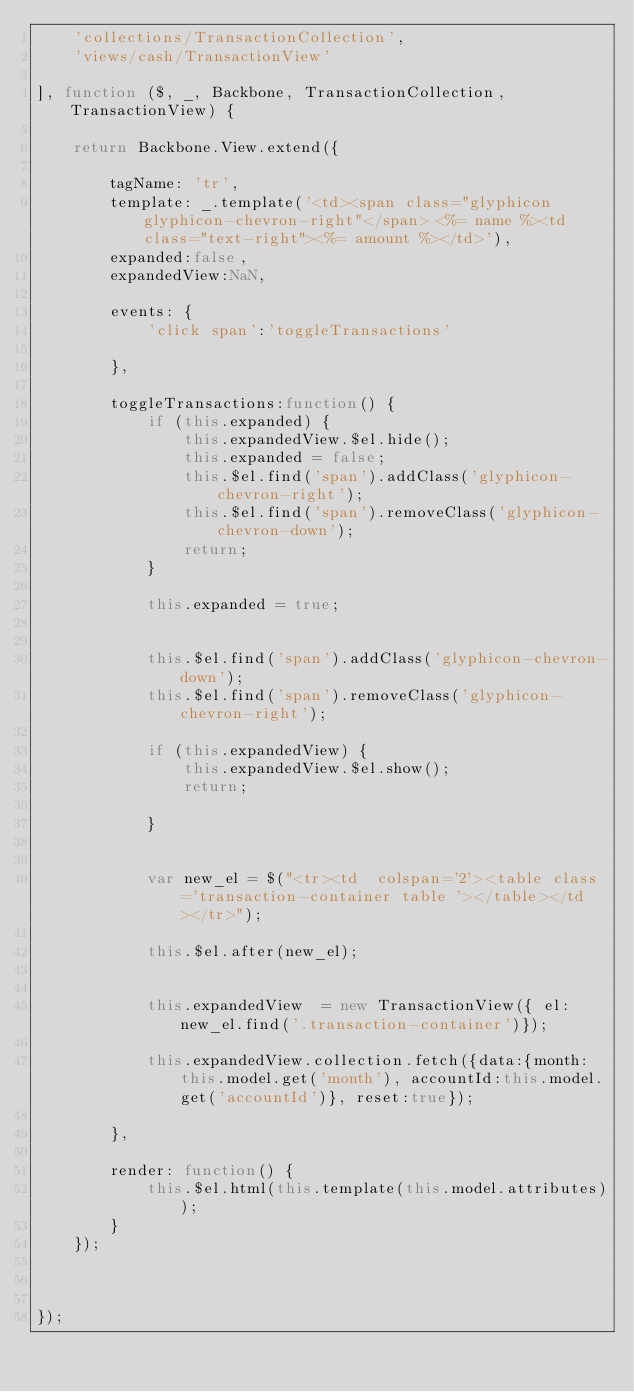<code> <loc_0><loc_0><loc_500><loc_500><_JavaScript_>    'collections/TransactionCollection',
    'views/cash/TransactionView'

], function ($, _, Backbone, TransactionCollection, TransactionView) {

    return Backbone.View.extend({

        tagName: 'tr',
        template: _.template('<td><span class="glyphicon glyphicon-chevron-right"</span> <%= name %><td class="text-right"><%= amount %></td>'),
        expanded:false,
        expandedView:NaN,

        events: {
            'click span':'toggleTransactions'

        },

        toggleTransactions:function() {
            if (this.expanded) {
                this.expandedView.$el.hide();
                this.expanded = false;
                this.$el.find('span').addClass('glyphicon-chevron-right');
                this.$el.find('span').removeClass('glyphicon-chevron-down');
                return;
            }

            this.expanded = true;


            this.$el.find('span').addClass('glyphicon-chevron-down');
            this.$el.find('span').removeClass('glyphicon-chevron-right');

            if (this.expandedView) {
                this.expandedView.$el.show();
                return;

            }


            var new_el = $("<tr><td  colspan='2'><table class='transaction-container table '></table></td></tr>");

            this.$el.after(new_el);


            this.expandedView  = new TransactionView({ el:new_el.find('.transaction-container')});

            this.expandedView.collection.fetch({data:{month:this.model.get('month'), accountId:this.model.get('accountId')}, reset:true});

        },

        render: function() {
            this.$el.html(this.template(this.model.attributes));
        }
    });



});
</code> 